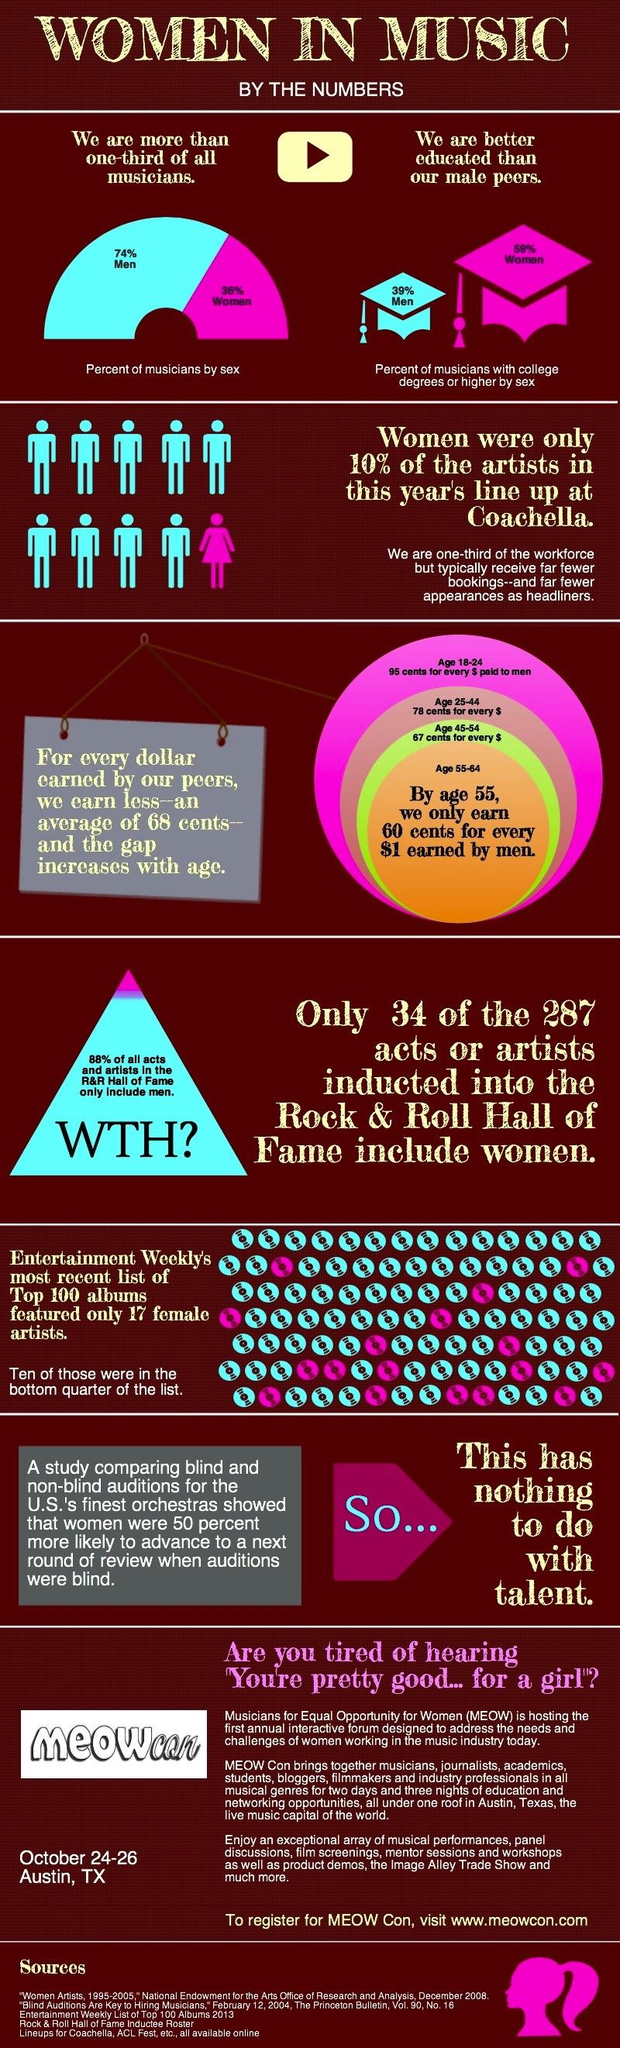Identify some key points in this picture. According to a recent study, a significant majority of musicians, approximately 74%, are men. According to a recent survey, 59% of musicians who hold a college degree or higher are women. 